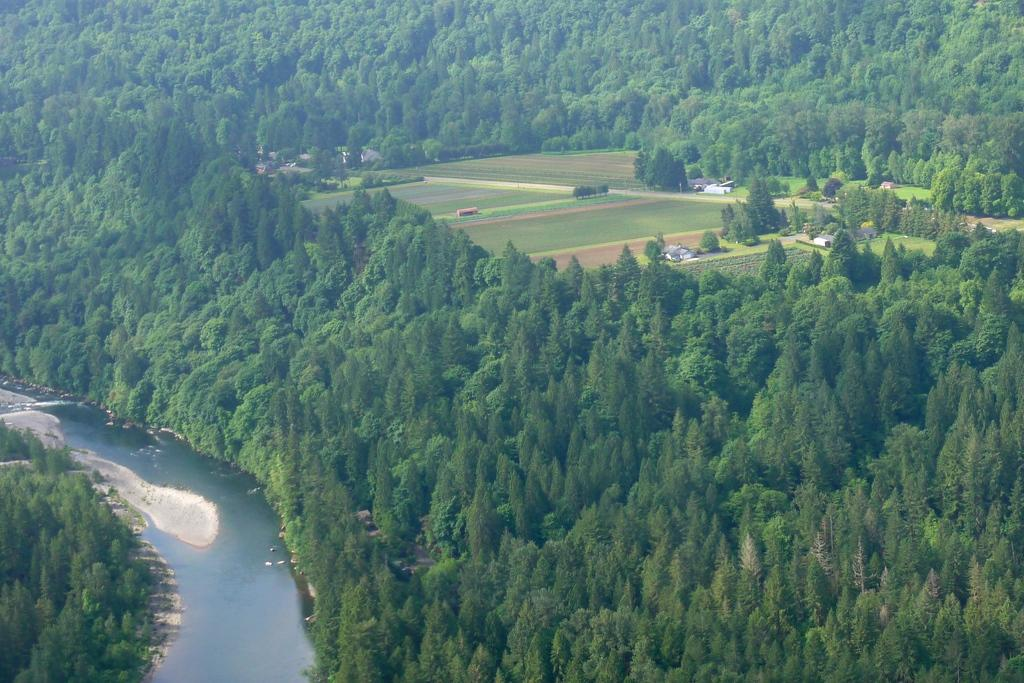What is the primary element visible in the image? There is water in the image. What type of vegetation can be seen near the water? There are many trees visible near the water. What is the surface on which the water and trees are situated? The ground is visible in the image. What is the opinion of the root in the image? There is no root present in the image, so it is not possible to determine its opinion. 